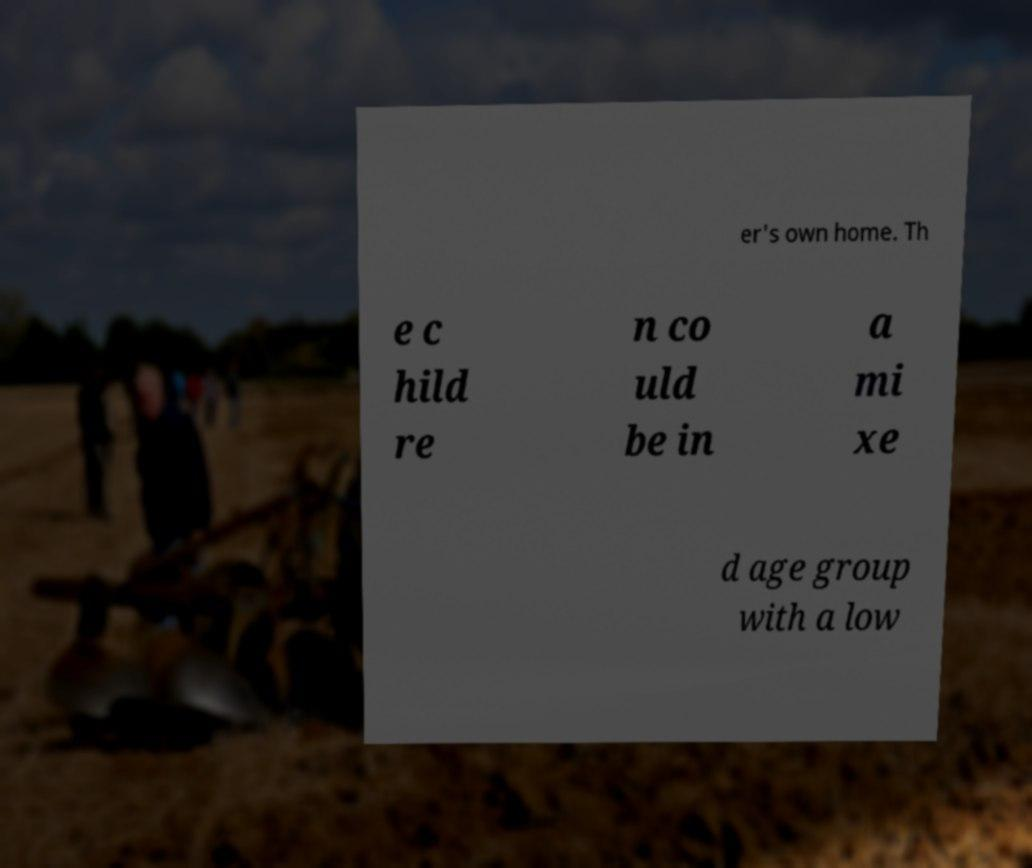Can you accurately transcribe the text from the provided image for me? er's own home. Th e c hild re n co uld be in a mi xe d age group with a low 